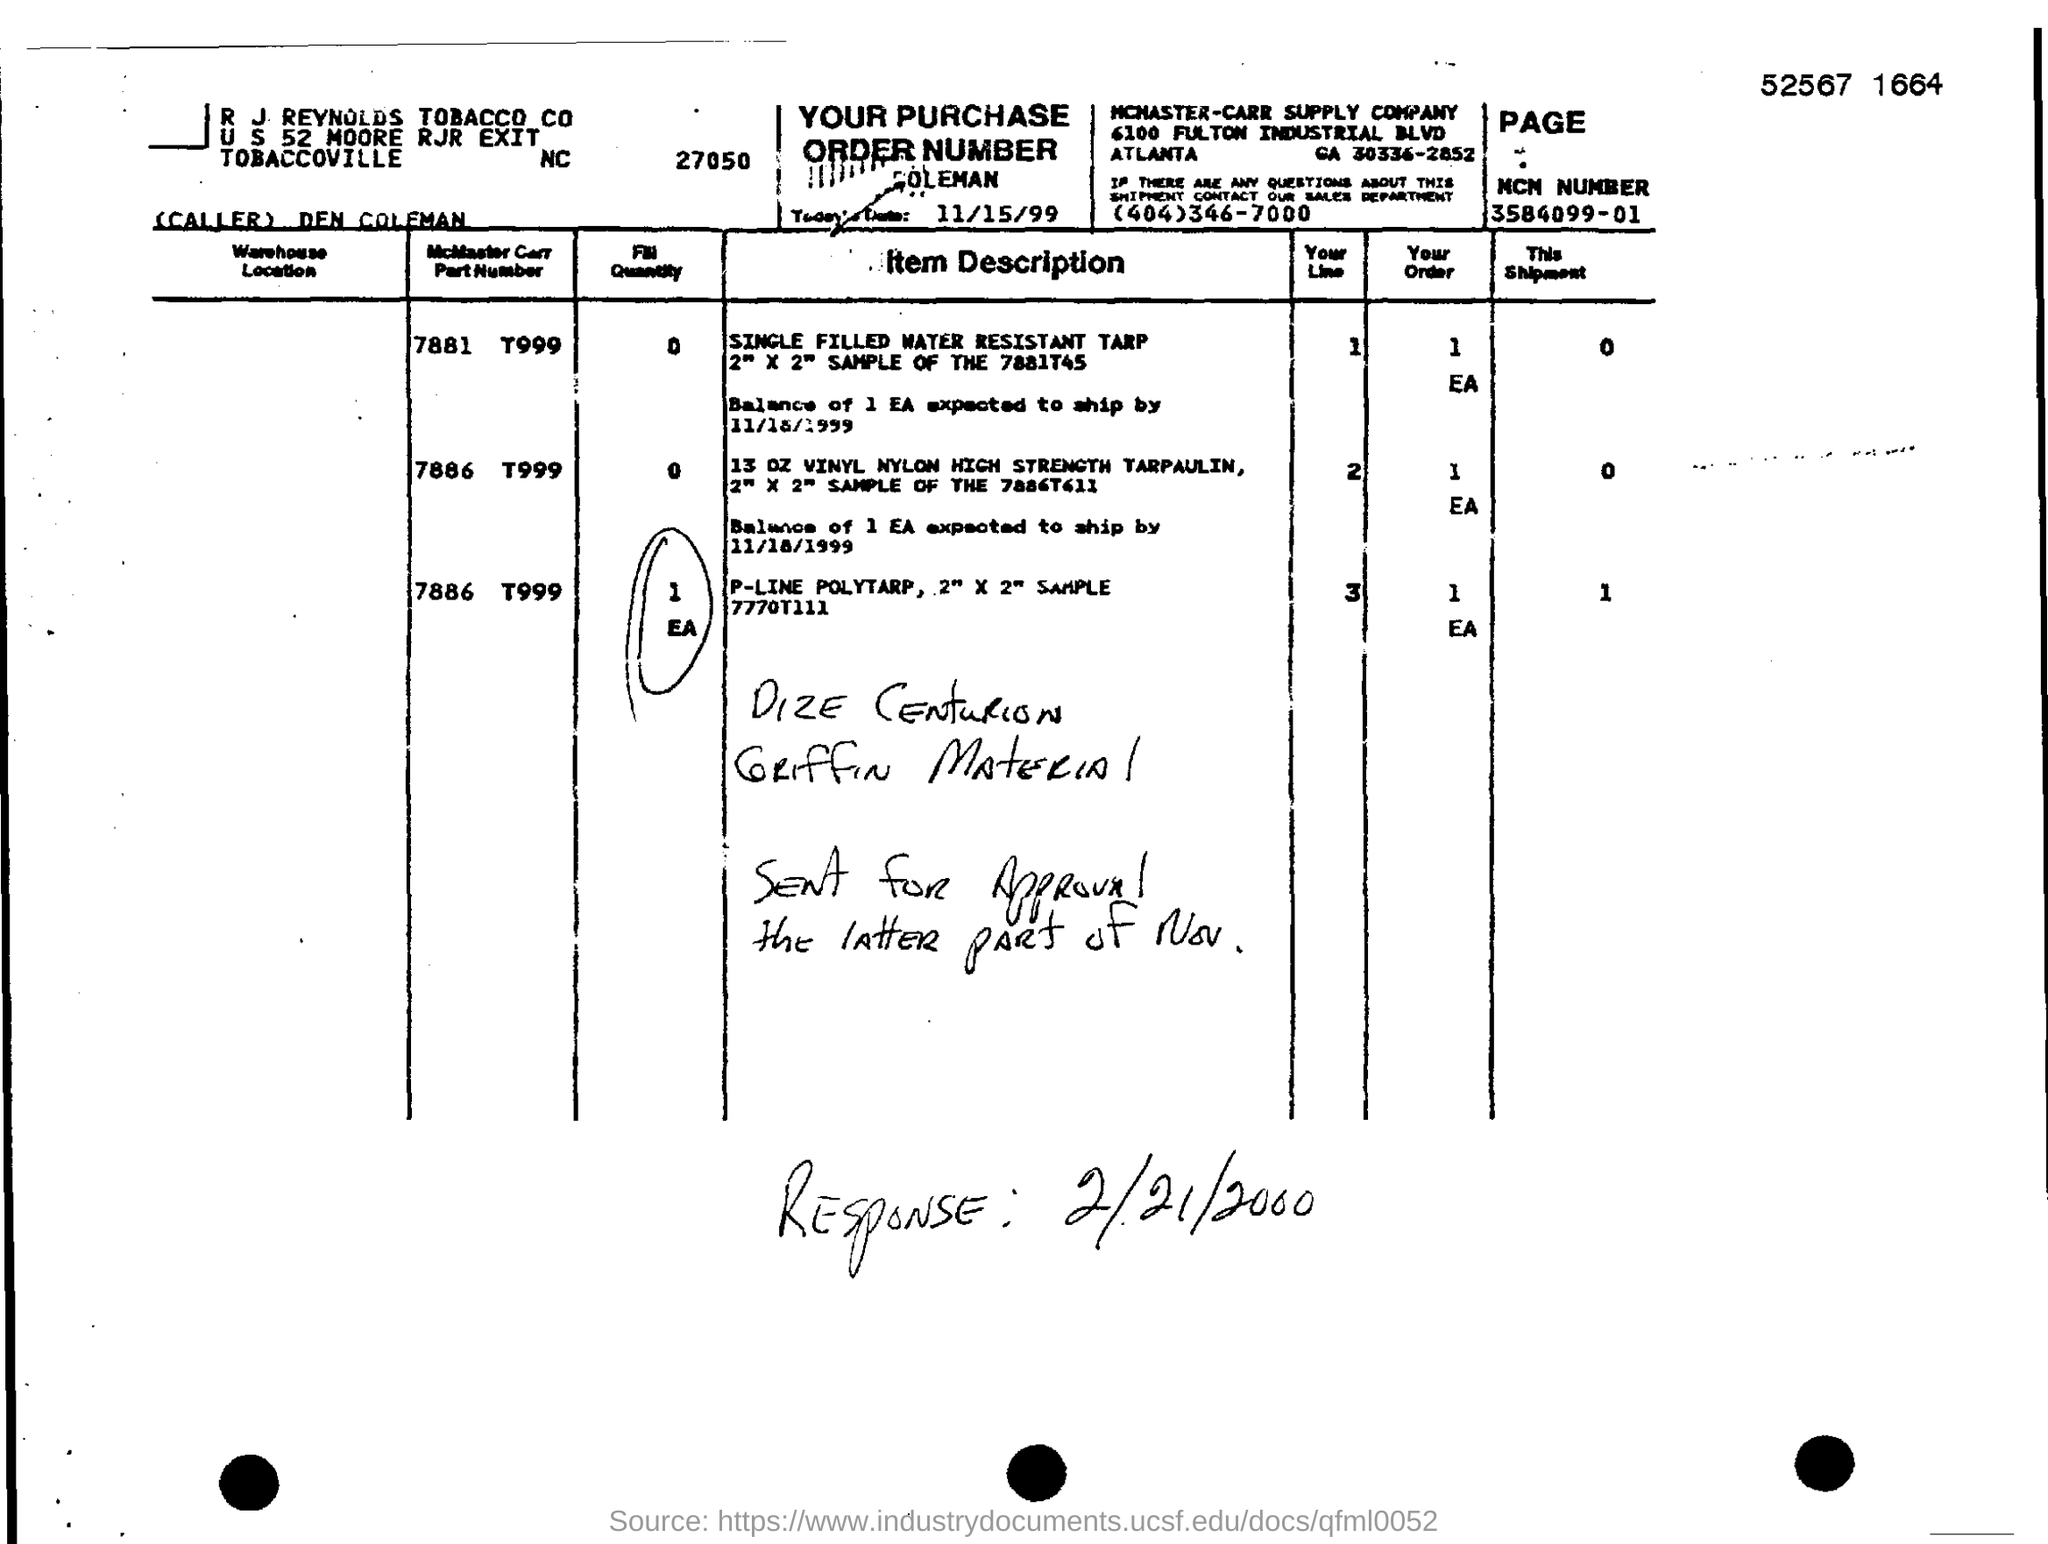Date of purchase order?
Your answer should be very brief. 11/15/99. What is MCN number
Offer a very short reply. 3584099-01. 